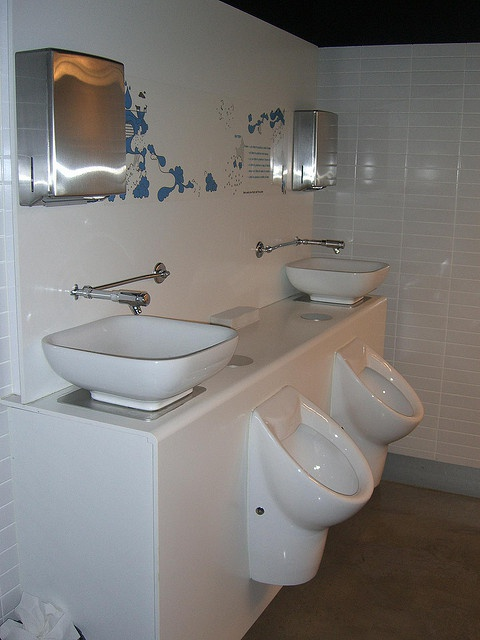Describe the objects in this image and their specific colors. I can see toilet in gray and darkgray tones, sink in gray, darkgray, and lightgray tones, and sink in gray tones in this image. 